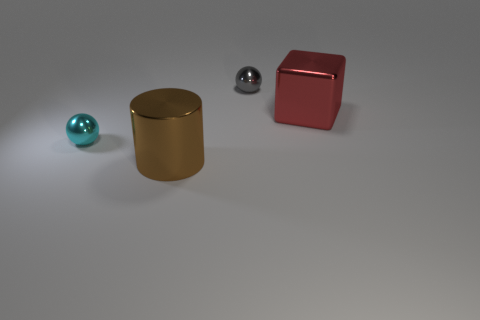What color is the object that is both in front of the gray shiny ball and behind the small cyan metallic thing?
Offer a terse response. Red. Does the shiny cylinder that is in front of the gray ball have the same size as the small gray thing?
Offer a very short reply. No. What number of things are either large things that are left of the large cube or tiny balls?
Provide a short and direct response. 3. Is there a brown shiny object that has the same size as the gray ball?
Your answer should be compact. No. There is a object that is the same size as the gray sphere; what material is it?
Provide a short and direct response. Metal. There is a thing that is behind the cyan sphere and to the left of the large cube; what shape is it?
Keep it short and to the point. Sphere. There is a small metallic sphere that is in front of the big block; what color is it?
Your answer should be very brief. Cyan. What is the size of the thing that is right of the cyan metal thing and in front of the red block?
Ensure brevity in your answer.  Large. Does the gray ball have the same material as the small thing that is on the left side of the small gray metallic object?
Your response must be concise. Yes. How many red things are the same shape as the gray thing?
Provide a short and direct response. 0. 